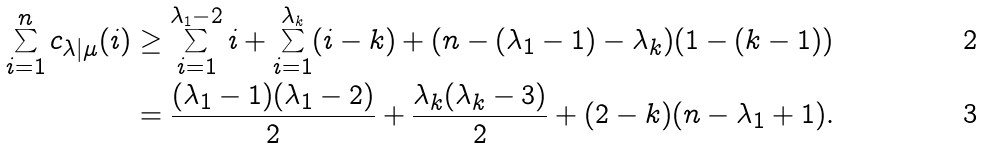<formula> <loc_0><loc_0><loc_500><loc_500>\sum _ { i = 1 } ^ { n } c _ { \lambda | \mu } ( i ) & \geq \sum _ { i = 1 } ^ { \lambda _ { 1 } - 2 } i + \sum _ { i = 1 } ^ { \lambda _ { k } } ( i - k ) + ( n - ( \lambda _ { 1 } - 1 ) - \lambda _ { k } ) ( 1 - ( k - 1 ) ) \\ & = \frac { ( \lambda _ { 1 } - 1 ) ( \lambda _ { 1 } - 2 ) } { 2 } + \frac { \lambda _ { k } ( \lambda _ { k } - 3 ) } { 2 } + ( 2 - k ) ( n - \lambda _ { 1 } + 1 ) .</formula> 